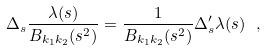Convert formula to latex. <formula><loc_0><loc_0><loc_500><loc_500>\Delta _ { s } \frac { \lambda ( s ) } { B _ { k _ { 1 } k _ { 2 } } ( s ^ { 2 } ) } = \frac { 1 } { B _ { k _ { 1 } k _ { 2 } } ( s ^ { 2 } ) } \Delta ^ { \prime } _ { s } \lambda ( s ) \ ,</formula> 